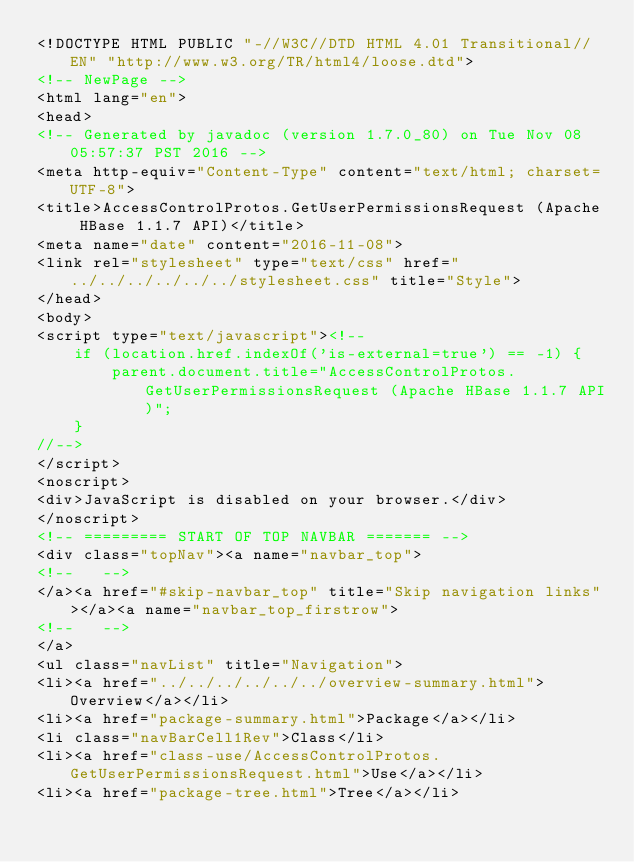Convert code to text. <code><loc_0><loc_0><loc_500><loc_500><_HTML_><!DOCTYPE HTML PUBLIC "-//W3C//DTD HTML 4.01 Transitional//EN" "http://www.w3.org/TR/html4/loose.dtd">
<!-- NewPage -->
<html lang="en">
<head>
<!-- Generated by javadoc (version 1.7.0_80) on Tue Nov 08 05:57:37 PST 2016 -->
<meta http-equiv="Content-Type" content="text/html; charset=UTF-8">
<title>AccessControlProtos.GetUserPermissionsRequest (Apache HBase 1.1.7 API)</title>
<meta name="date" content="2016-11-08">
<link rel="stylesheet" type="text/css" href="../../../../../../stylesheet.css" title="Style">
</head>
<body>
<script type="text/javascript"><!--
    if (location.href.indexOf('is-external=true') == -1) {
        parent.document.title="AccessControlProtos.GetUserPermissionsRequest (Apache HBase 1.1.7 API)";
    }
//-->
</script>
<noscript>
<div>JavaScript is disabled on your browser.</div>
</noscript>
<!-- ========= START OF TOP NAVBAR ======= -->
<div class="topNav"><a name="navbar_top">
<!--   -->
</a><a href="#skip-navbar_top" title="Skip navigation links"></a><a name="navbar_top_firstrow">
<!--   -->
</a>
<ul class="navList" title="Navigation">
<li><a href="../../../../../../overview-summary.html">Overview</a></li>
<li><a href="package-summary.html">Package</a></li>
<li class="navBarCell1Rev">Class</li>
<li><a href="class-use/AccessControlProtos.GetUserPermissionsRequest.html">Use</a></li>
<li><a href="package-tree.html">Tree</a></li></code> 